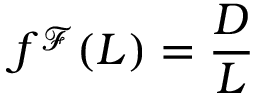<formula> <loc_0><loc_0><loc_500><loc_500>f ^ { \mathcal { F } } ( L ) = \frac { D } { L }</formula> 